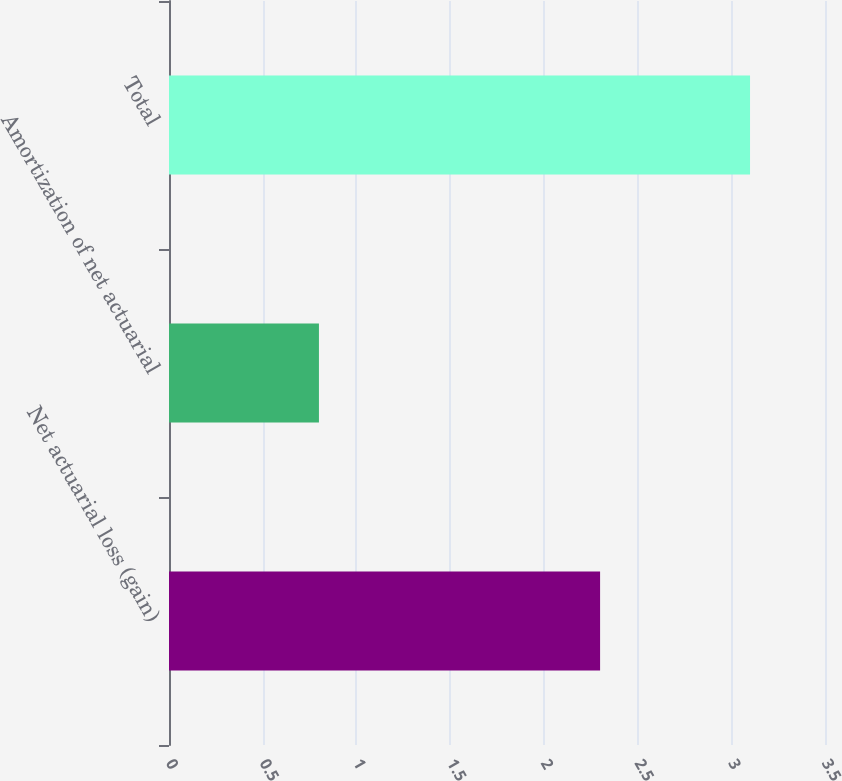Convert chart. <chart><loc_0><loc_0><loc_500><loc_500><bar_chart><fcel>Net actuarial loss (gain)<fcel>Amortization of net actuarial<fcel>Total<nl><fcel>2.3<fcel>0.8<fcel>3.1<nl></chart> 